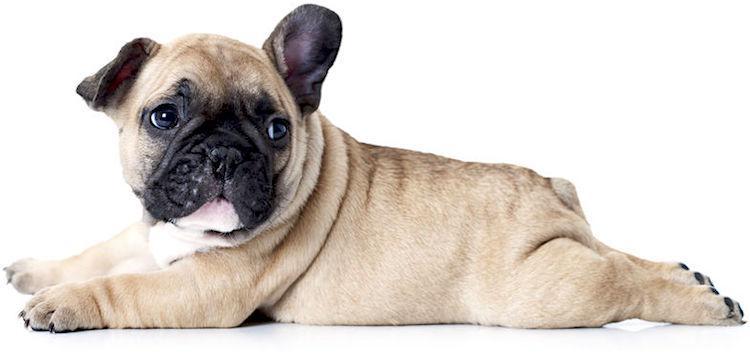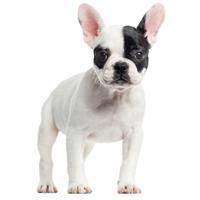The first image is the image on the left, the second image is the image on the right. Considering the images on both sides, is "The left image contains exactly two dogs that are seated next to each other." valid? Answer yes or no. No. The first image is the image on the left, the second image is the image on the right. Assess this claim about the two images: "An image contains exactly two side-by-side dogs, with a black one on the left and a white-bodied dog on the right.". Correct or not? Answer yes or no. No. 